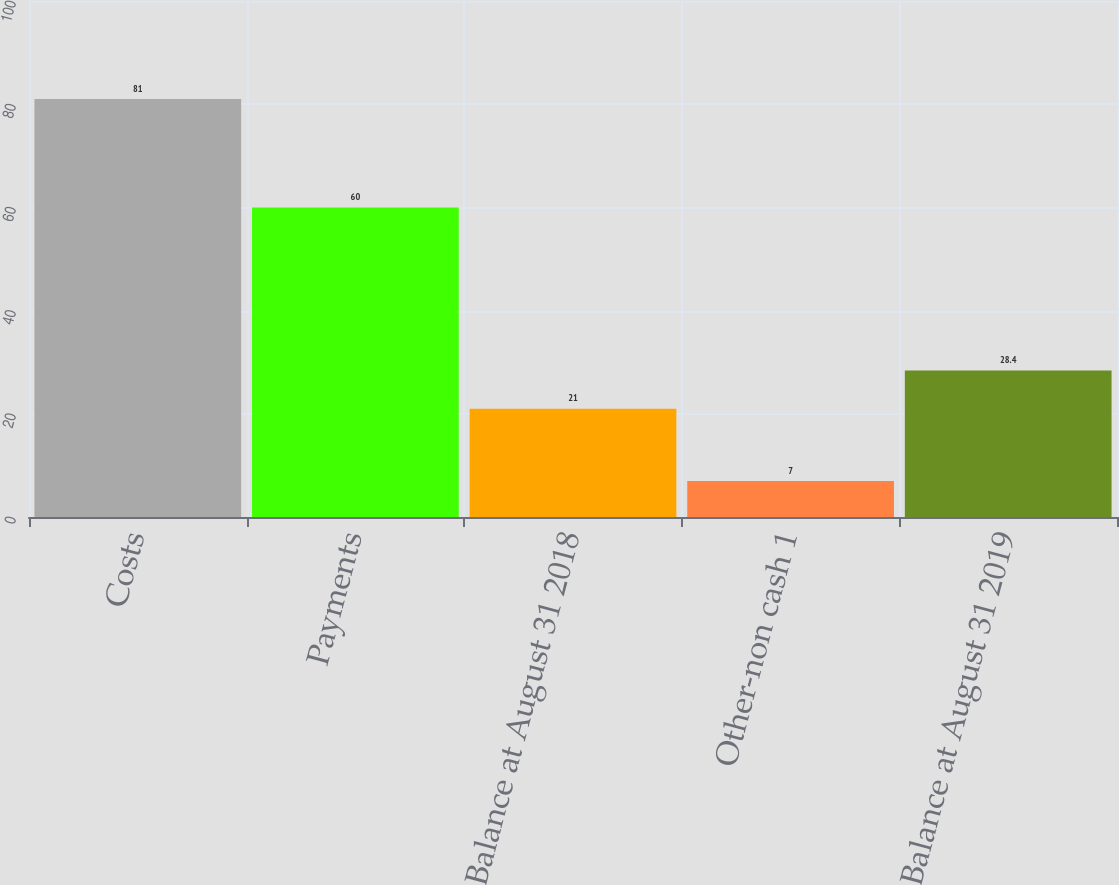Convert chart. <chart><loc_0><loc_0><loc_500><loc_500><bar_chart><fcel>Costs<fcel>Payments<fcel>Balance at August 31 2018<fcel>Other-non cash 1<fcel>Balance at August 31 2019<nl><fcel>81<fcel>60<fcel>21<fcel>7<fcel>28.4<nl></chart> 